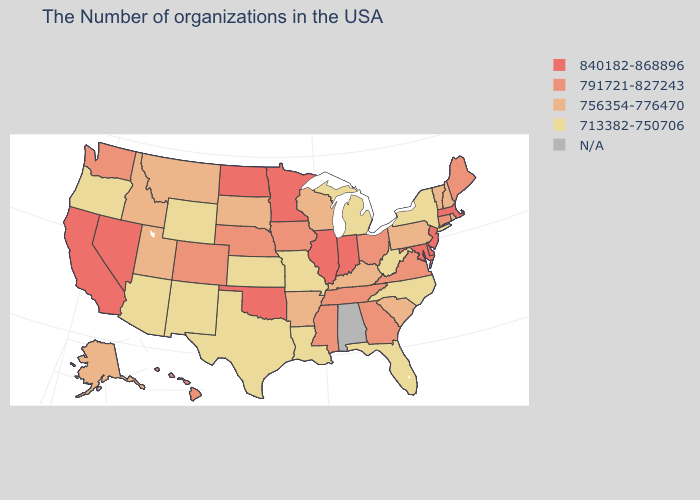What is the lowest value in the USA?
Quick response, please. 713382-750706. Name the states that have a value in the range 713382-750706?
Concise answer only. New York, North Carolina, West Virginia, Florida, Michigan, Louisiana, Missouri, Kansas, Texas, Wyoming, New Mexico, Arizona, Oregon. What is the highest value in states that border Wyoming?
Short answer required. 791721-827243. Does the map have missing data?
Give a very brief answer. Yes. What is the value of Vermont?
Short answer required. 756354-776470. Which states have the highest value in the USA?
Be succinct. Massachusetts, New Jersey, Delaware, Maryland, Indiana, Illinois, Minnesota, Oklahoma, North Dakota, Nevada, California. Name the states that have a value in the range 713382-750706?
Give a very brief answer. New York, North Carolina, West Virginia, Florida, Michigan, Louisiana, Missouri, Kansas, Texas, Wyoming, New Mexico, Arizona, Oregon. What is the value of Colorado?
Concise answer only. 791721-827243. Does the first symbol in the legend represent the smallest category?
Give a very brief answer. No. Which states have the lowest value in the USA?
Be succinct. New York, North Carolina, West Virginia, Florida, Michigan, Louisiana, Missouri, Kansas, Texas, Wyoming, New Mexico, Arizona, Oregon. Name the states that have a value in the range 756354-776470?
Answer briefly. Rhode Island, New Hampshire, Vermont, Pennsylvania, South Carolina, Kentucky, Wisconsin, Arkansas, South Dakota, Utah, Montana, Idaho, Alaska. What is the value of Oregon?
Be succinct. 713382-750706. How many symbols are there in the legend?
Give a very brief answer. 5. What is the highest value in states that border Iowa?
Write a very short answer. 840182-868896. 